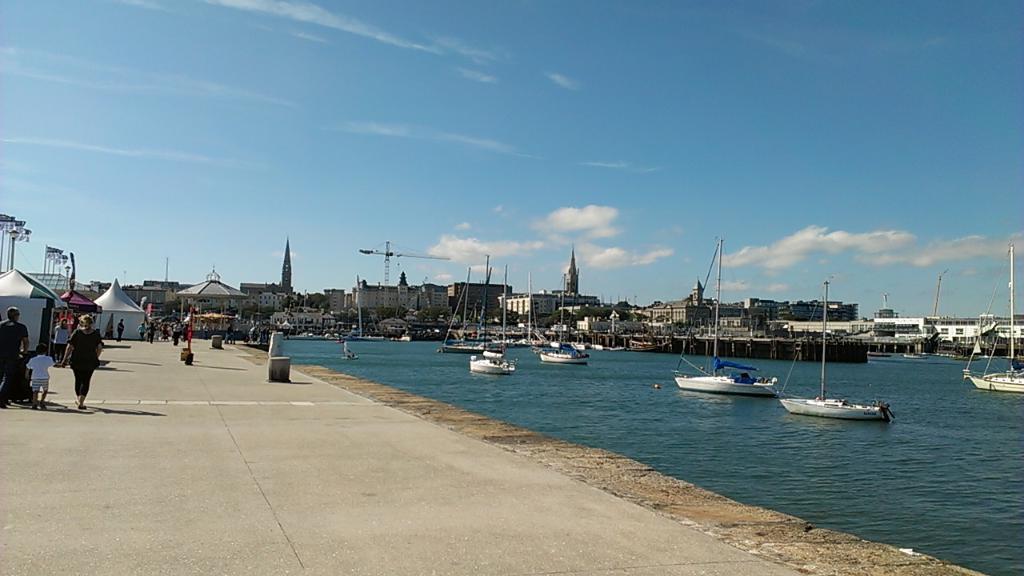Please provide a concise description of this image. In this picture we can see a lake with blue water and few boats in white color which are sailing on it and here on the left side we have a road on which a lady in black shirt is walking along with her child in white shirt and the sky is totally blue here. we have tents here and few people in the background. 